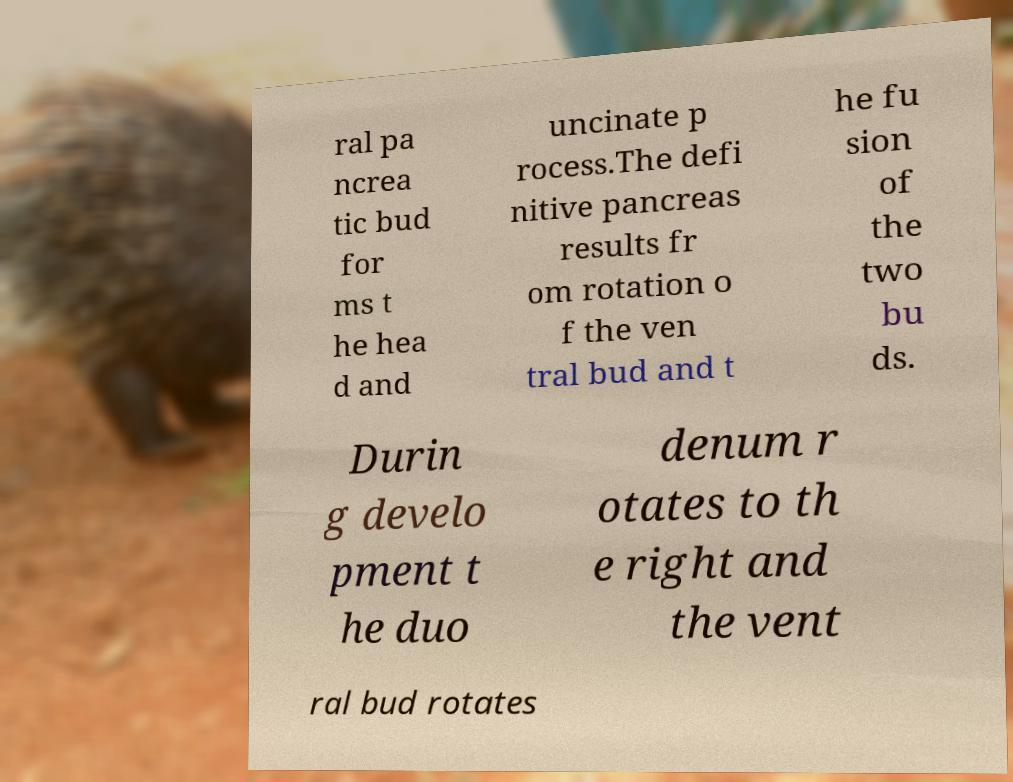Could you assist in decoding the text presented in this image and type it out clearly? ral pa ncrea tic bud for ms t he hea d and uncinate p rocess.The defi nitive pancreas results fr om rotation o f the ven tral bud and t he fu sion of the two bu ds. Durin g develo pment t he duo denum r otates to th e right and the vent ral bud rotates 